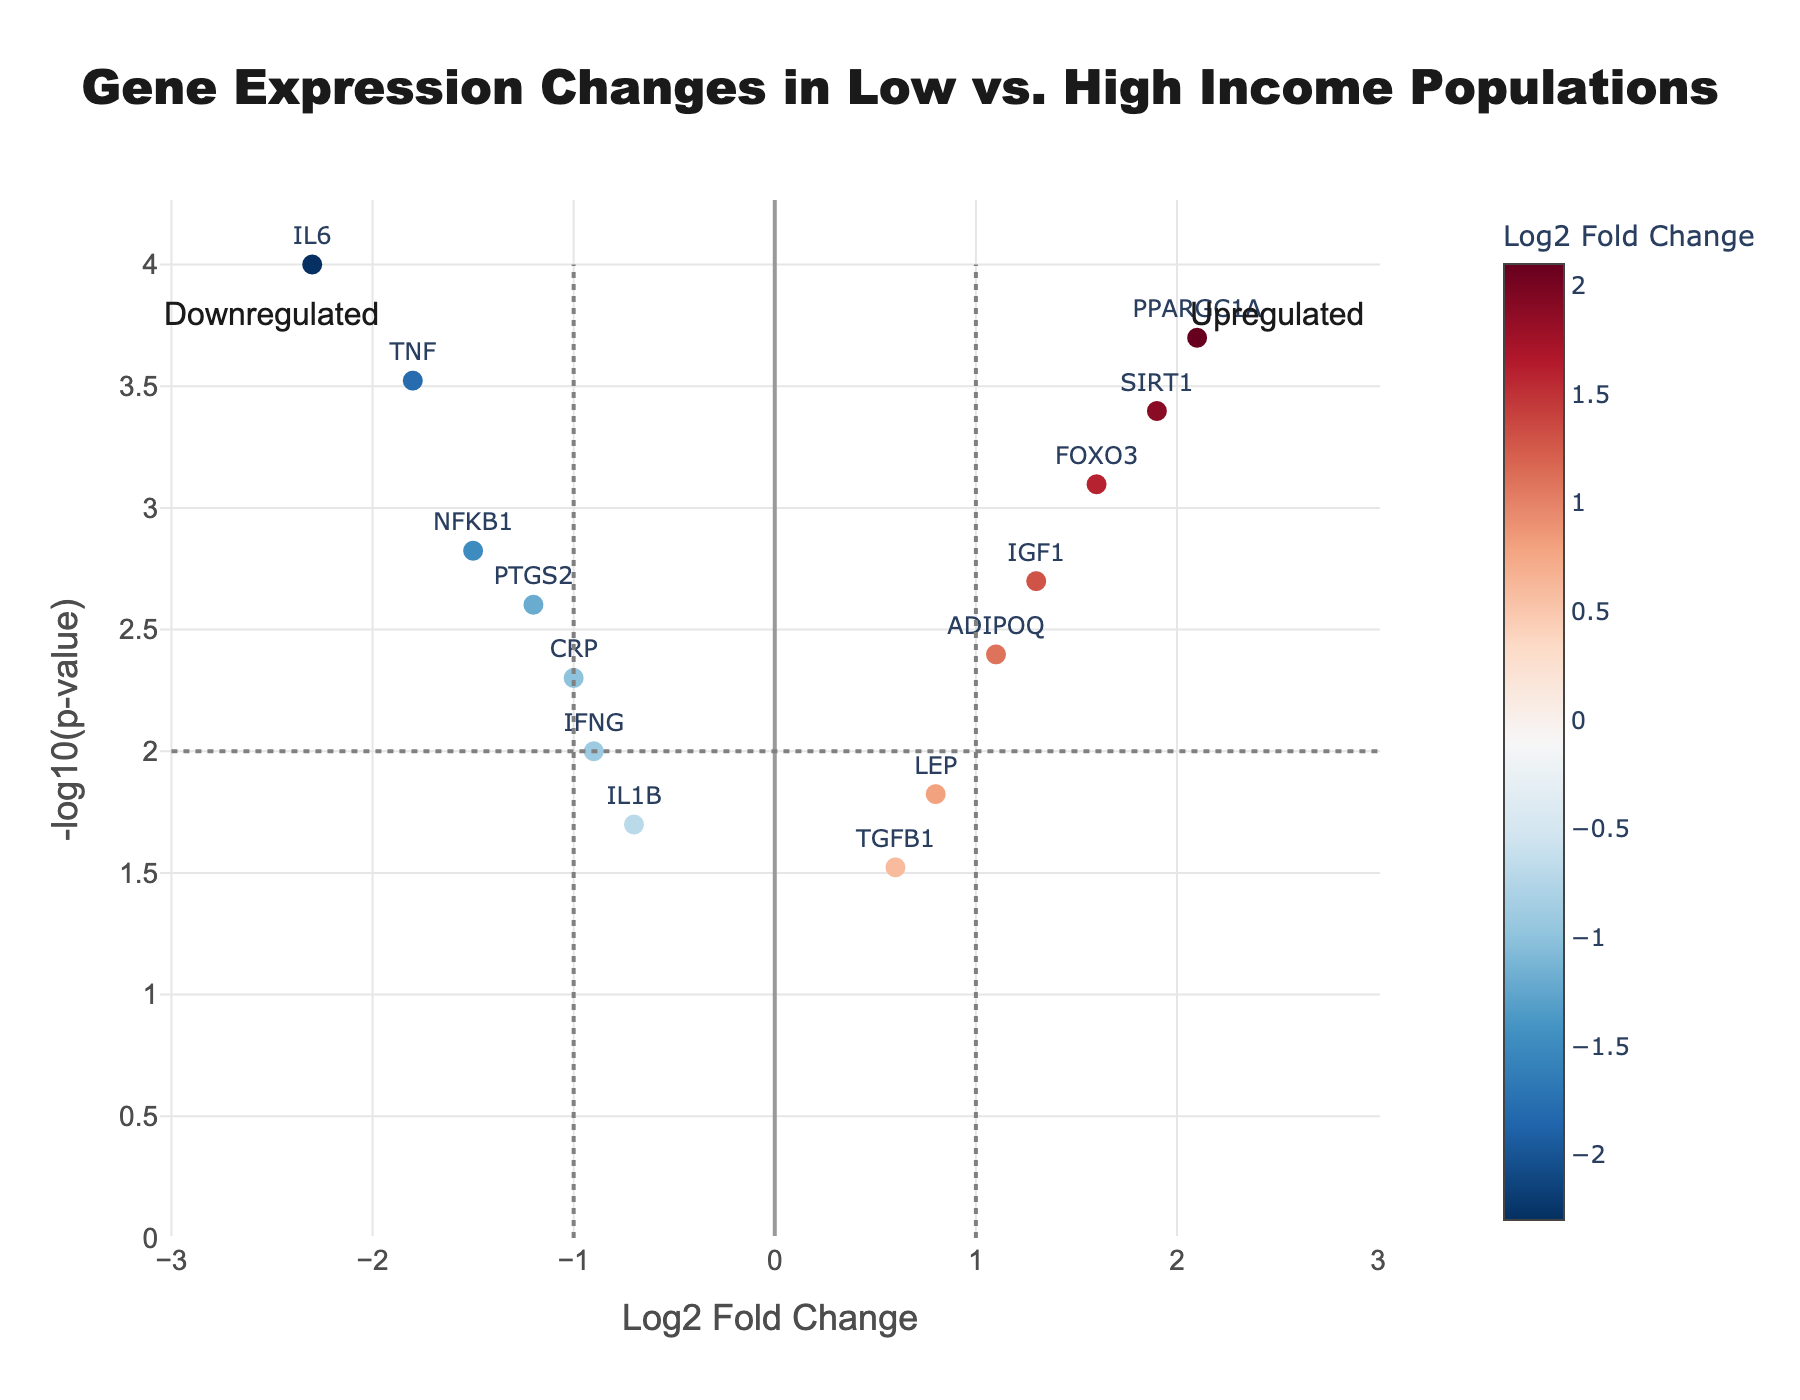Which gene shows the highest Log2 fold change? The gene with the highest position on the x-axis represents the highest Log2 fold change in the plot. Isolate the point farthest to the right.
Answer: PPARGC1A Which gene has the lowest p-value? The lowest p-value will correspond to the highest point on the y-axis since the y-axis represents -log10(p-value). Identify the point at the highest vertical position.
Answer: IL6 Which gene is most significantly upregulated? An upregulated gene will have a Log2 fold change greater than 0. The highest -log10(p-value) among these points will indicate the most significant upregulation. Find the highest point on the right half of the plot.
Answer: PPARGC1A How many genes are upregulated vs. downregulated? Count the points on the right side of the vertical line at Log2 fold change = 0 for upregulated genes and on the left for downregulated genes.
Answer: 5 upregulated, 7 downregulated Which gene is more significantly downregulated, IL6 or TNF? Both genes are on the left side indicating downregulation. Among these, compare their -log10(p-value) values; the higher one indicates more significant downregulation.
Answer: IL6 What is the Log2 fold change of ADIPOQ, and is it upregulated or downregulated? Locate ADIPOQ on the plot and check its position on the x-axis. Positive values indicate upregulation, and negative values indicate downregulation.
Answer: 1.1, upregulated Which has a higher -log10(p-value), IGF1 or SIRT1? Identify the points corresponding to IGF1 and SIRT1 on the plot and compare their vertical positions. The higher position indicates a higher -log10(p-value).
Answer: SIRT1 What do the dashed vertical lines at Log2 fold changes of -1 and 1 represent? The vertical dashed lines at these x-values usually represent threshold values, often indicating genes with noteworthy fold changes are beyond these lines.
Answer: Thresholds for significant fold changes What can you infer about the expression of NFKB1 compared to TGFB1? Compare their positions relative to the vertical centerline and horizontal thresholds. NFKB1 is downregulated, shown by its position left of the centerline, while TGFB1 is slightly upregulated, right of the centerline.
Answer: NFKB1 is downregulated; TGFB1 is upregulated 